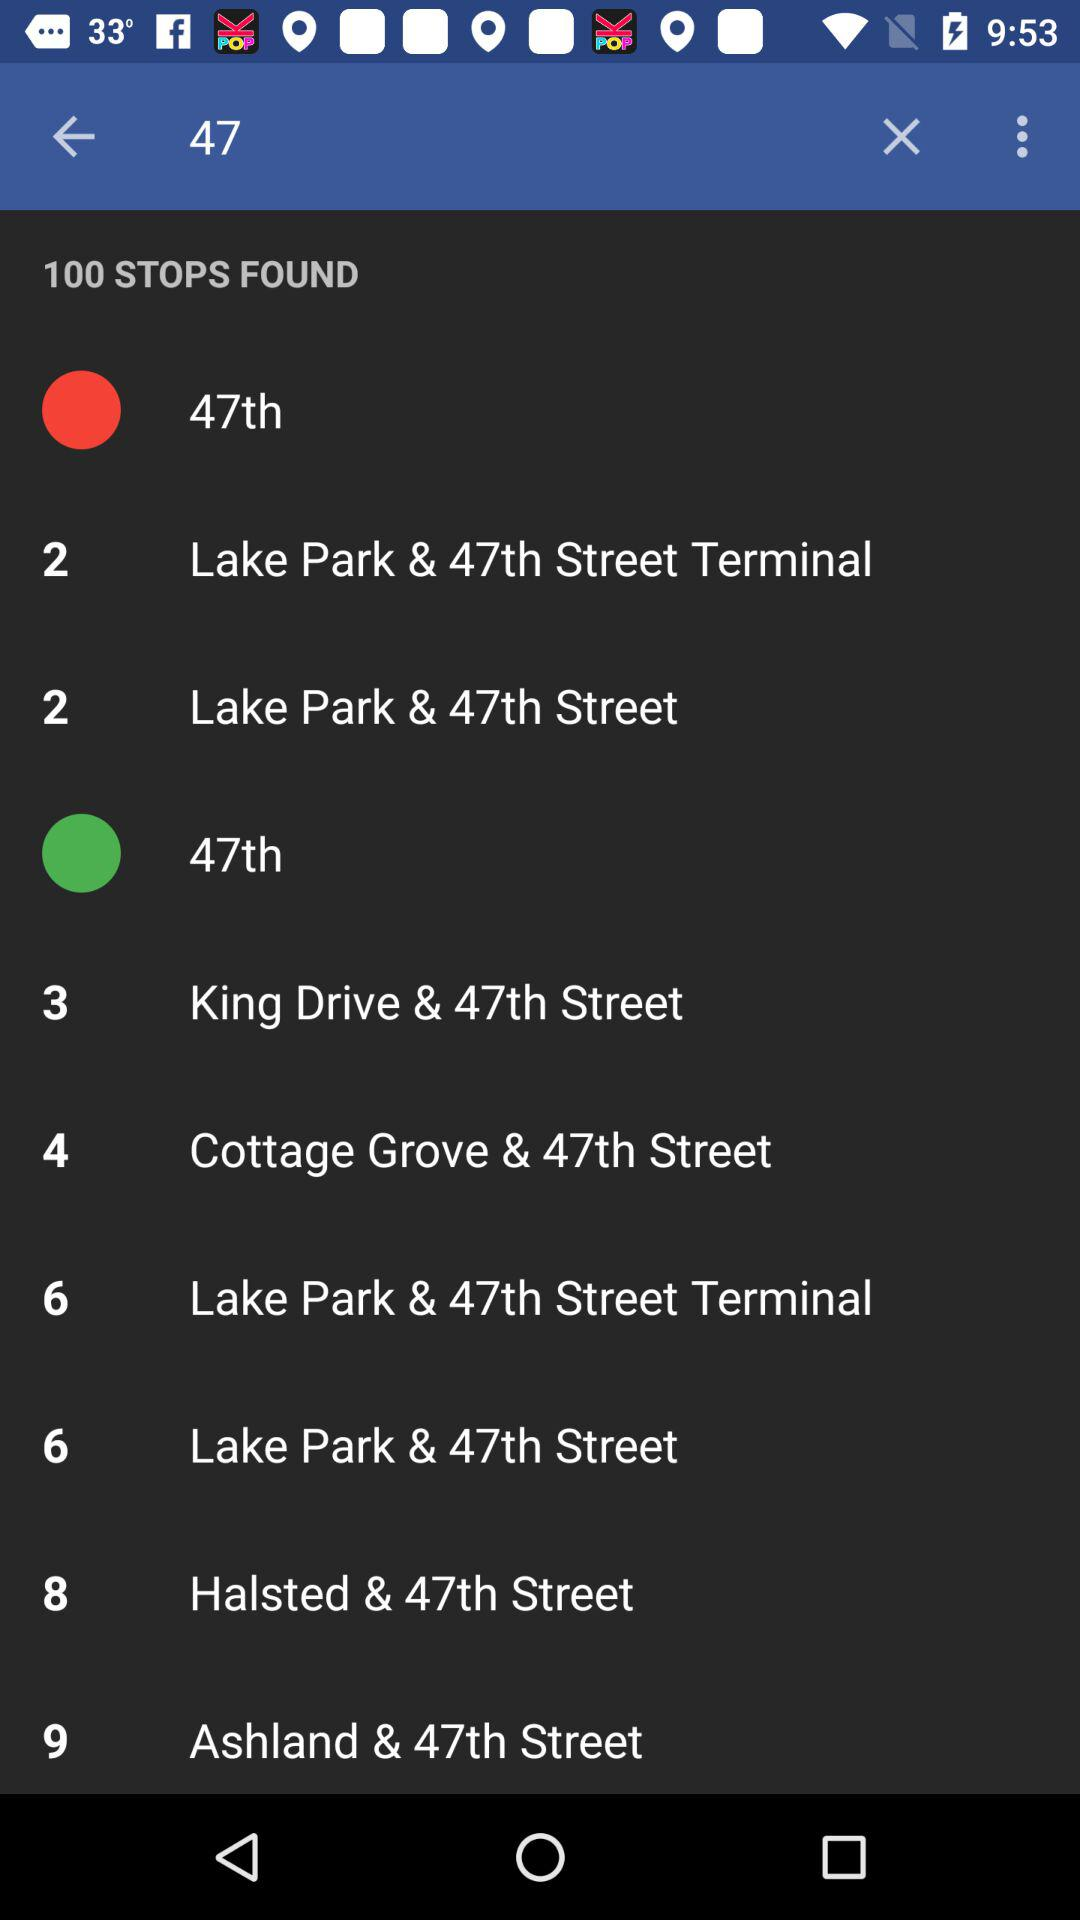What is the name of the application?
When the provided information is insufficient, respond with <no answer>. <no answer> 